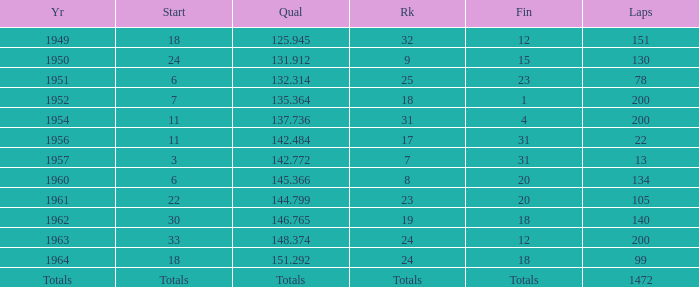Determine the placement for 151 laps 32.0. 